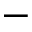<formula> <loc_0><loc_0><loc_500><loc_500>-</formula> 